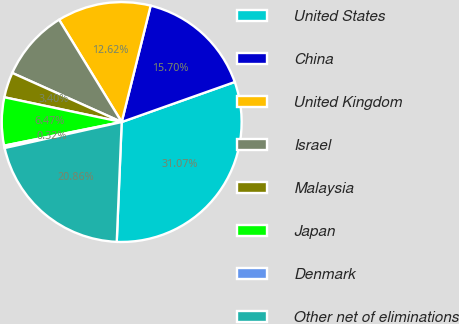Convert chart to OTSL. <chart><loc_0><loc_0><loc_500><loc_500><pie_chart><fcel>United States<fcel>China<fcel>United Kingdom<fcel>Israel<fcel>Malaysia<fcel>Japan<fcel>Denmark<fcel>Other net of eliminations<nl><fcel>31.07%<fcel>15.7%<fcel>12.62%<fcel>9.55%<fcel>3.4%<fcel>6.47%<fcel>0.32%<fcel>20.86%<nl></chart> 